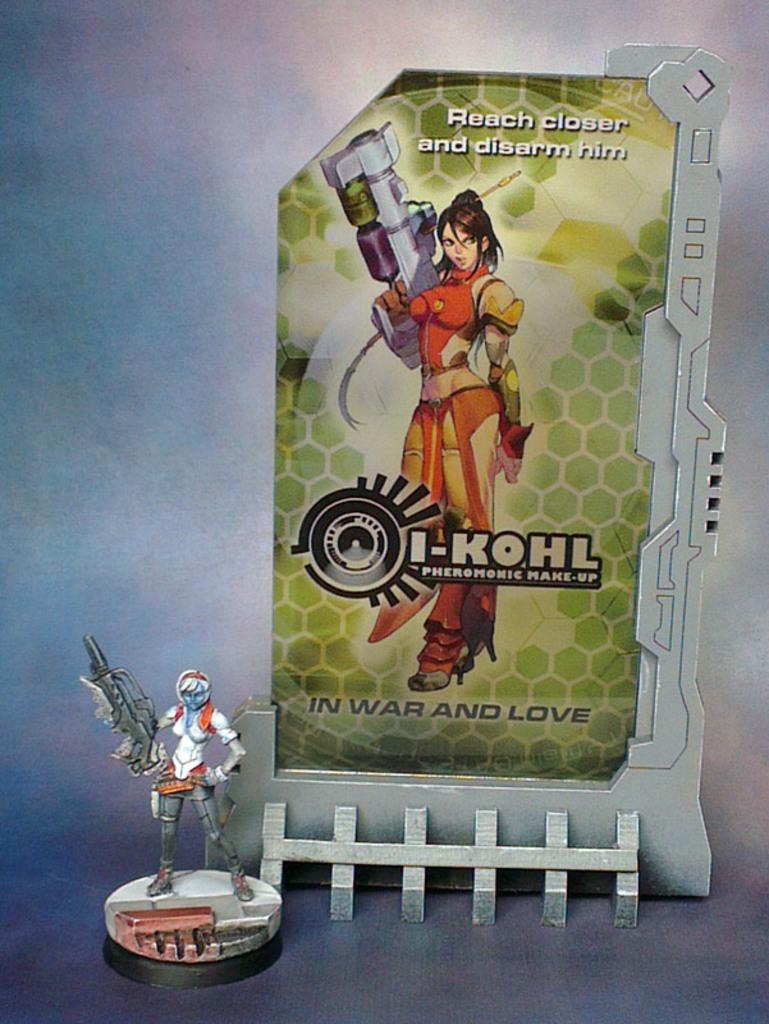Provide a one-sentence caption for the provided image. an ad for i-kohl makeup with a figure in front of it. 